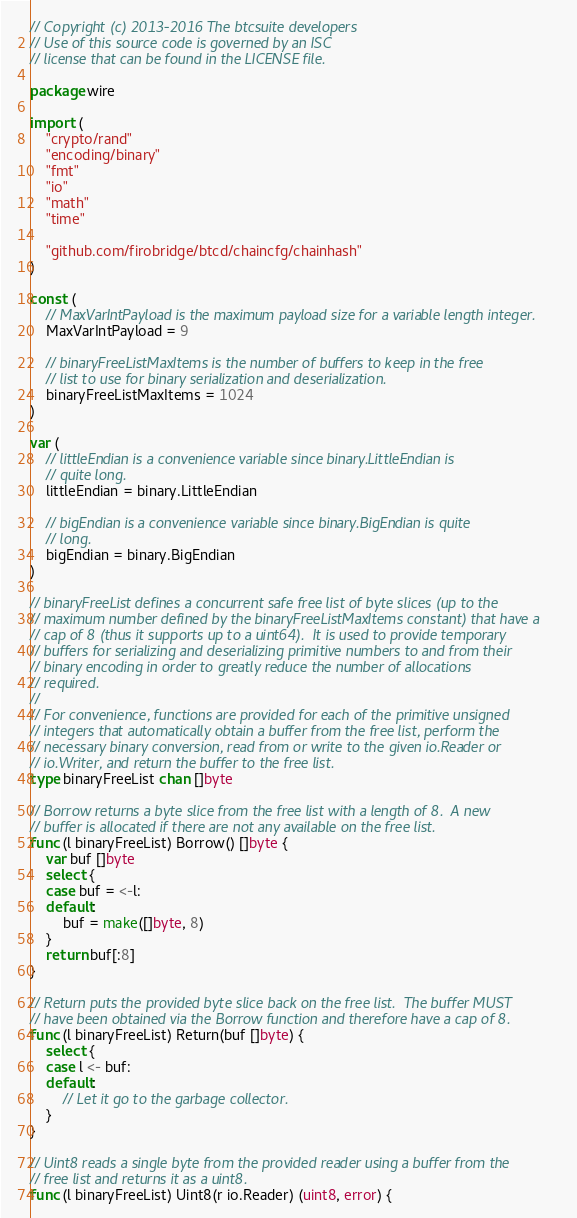<code> <loc_0><loc_0><loc_500><loc_500><_Go_>// Copyright (c) 2013-2016 The btcsuite developers
// Use of this source code is governed by an ISC
// license that can be found in the LICENSE file.

package wire

import (
	"crypto/rand"
	"encoding/binary"
	"fmt"
	"io"
	"math"
	"time"

	"github.com/firobridge/btcd/chaincfg/chainhash"
)

const (
	// MaxVarIntPayload is the maximum payload size for a variable length integer.
	MaxVarIntPayload = 9

	// binaryFreeListMaxItems is the number of buffers to keep in the free
	// list to use for binary serialization and deserialization.
	binaryFreeListMaxItems = 1024
)

var (
	// littleEndian is a convenience variable since binary.LittleEndian is
	// quite long.
	littleEndian = binary.LittleEndian

	// bigEndian is a convenience variable since binary.BigEndian is quite
	// long.
	bigEndian = binary.BigEndian
)

// binaryFreeList defines a concurrent safe free list of byte slices (up to the
// maximum number defined by the binaryFreeListMaxItems constant) that have a
// cap of 8 (thus it supports up to a uint64).  It is used to provide temporary
// buffers for serializing and deserializing primitive numbers to and from their
// binary encoding in order to greatly reduce the number of allocations
// required.
//
// For convenience, functions are provided for each of the primitive unsigned
// integers that automatically obtain a buffer from the free list, perform the
// necessary binary conversion, read from or write to the given io.Reader or
// io.Writer, and return the buffer to the free list.
type binaryFreeList chan []byte

// Borrow returns a byte slice from the free list with a length of 8.  A new
// buffer is allocated if there are not any available on the free list.
func (l binaryFreeList) Borrow() []byte {
	var buf []byte
	select {
	case buf = <-l:
	default:
		buf = make([]byte, 8)
	}
	return buf[:8]
}

// Return puts the provided byte slice back on the free list.  The buffer MUST
// have been obtained via the Borrow function and therefore have a cap of 8.
func (l binaryFreeList) Return(buf []byte) {
	select {
	case l <- buf:
	default:
		// Let it go to the garbage collector.
	}
}

// Uint8 reads a single byte from the provided reader using a buffer from the
// free list and returns it as a uint8.
func (l binaryFreeList) Uint8(r io.Reader) (uint8, error) {</code> 